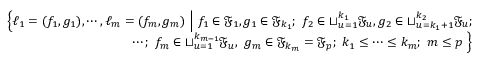<formula> <loc_0><loc_0><loc_500><loc_500>\begin{array} { r l r } & { \Big \{ \ell _ { 1 } = ( f _ { 1 } , g _ { 1 } ) , \cdots , \ell _ { m } = ( f _ { m } , g _ { m } ) \ \Big | \ f _ { 1 } \in { \mathfrak { F } } _ { 1 } , g _ { 1 } \in { \mathfrak { F } } _ { k _ { 1 } } ; \ f _ { 2 } \in \sqcup _ { u = 1 } ^ { k _ { 1 } } { \mathfrak { F } } _ { u } , g _ { 2 } \in \sqcup _ { u = k _ { 1 } + 1 } ^ { k _ { 2 } } { { \mathfrak { F } } _ { u } } ; } \\ & { \quad \cdots ; \ f _ { m } \in \sqcup _ { u = 1 } ^ { k _ { m - 1 } } { \mathfrak { F } } _ { u } , \ g _ { m } \in { \mathfrak { F } } _ { k _ { m } } = { \mathfrak { F } } _ { p } ; \ k _ { 1 } \leq \cdots \leq k _ { m } ; \ m \leq p \ \Big \} } \end{array}</formula> 